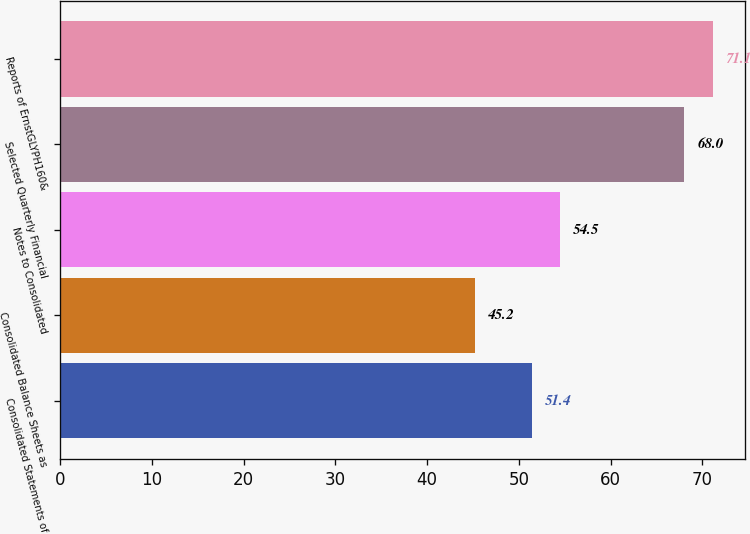Convert chart. <chart><loc_0><loc_0><loc_500><loc_500><bar_chart><fcel>Consolidated Statements of<fcel>Consolidated Balance Sheets as<fcel>Notes to Consolidated<fcel>Selected Quarterly Financial<fcel>Reports of ErnstGLYPH160&<nl><fcel>51.4<fcel>45.2<fcel>54.5<fcel>68<fcel>71.1<nl></chart> 